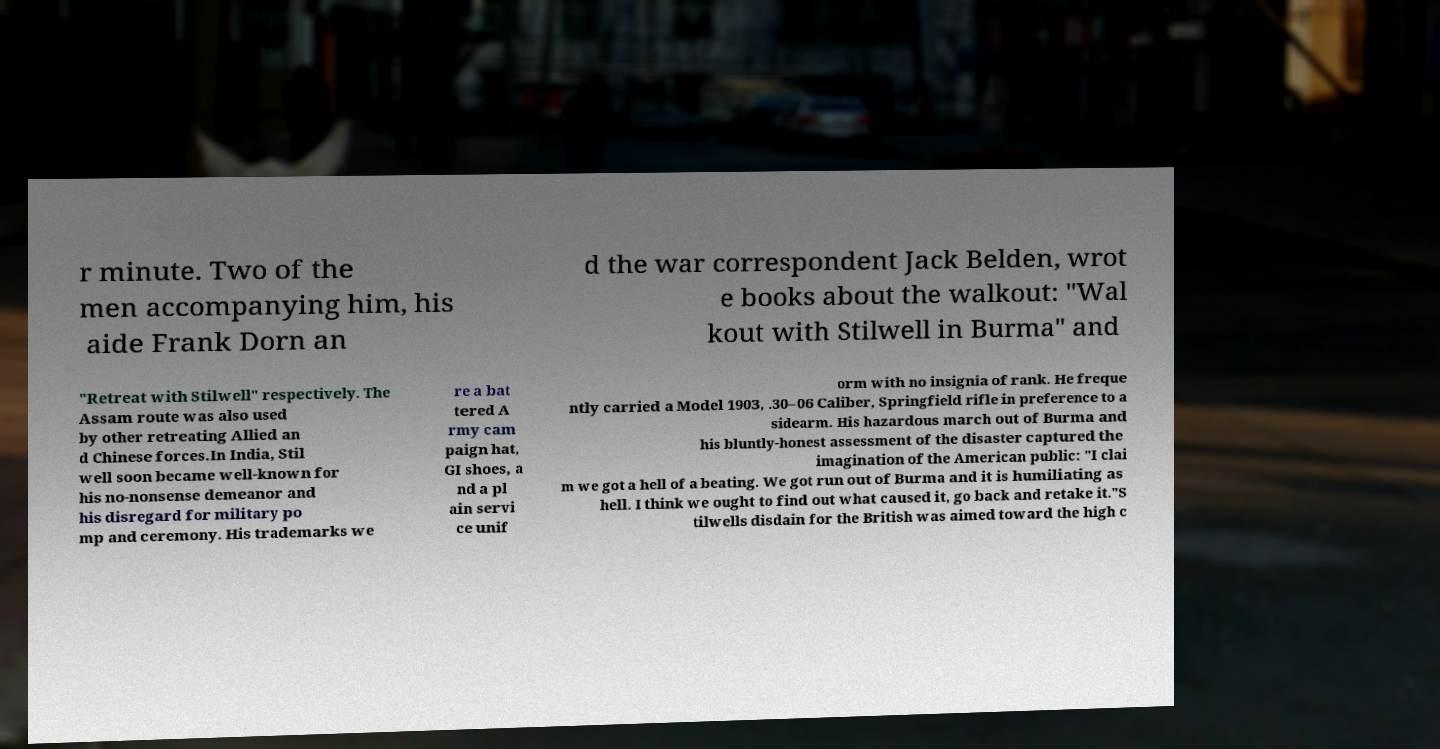What messages or text are displayed in this image? I need them in a readable, typed format. r minute. Two of the men accompanying him, his aide Frank Dorn an d the war correspondent Jack Belden, wrot e books about the walkout: "Wal kout with Stilwell in Burma" and "Retreat with Stilwell" respectively. The Assam route was also used by other retreating Allied an d Chinese forces.In India, Stil well soon became well-known for his no-nonsense demeanor and his disregard for military po mp and ceremony. His trademarks we re a bat tered A rmy cam paign hat, GI shoes, a nd a pl ain servi ce unif orm with no insignia of rank. He freque ntly carried a Model 1903, .30–06 Caliber, Springfield rifle in preference to a sidearm. His hazardous march out of Burma and his bluntly-honest assessment of the disaster captured the imagination of the American public: "I clai m we got a hell of a beating. We got run out of Burma and it is humiliating as hell. I think we ought to find out what caused it, go back and retake it."S tilwells disdain for the British was aimed toward the high c 